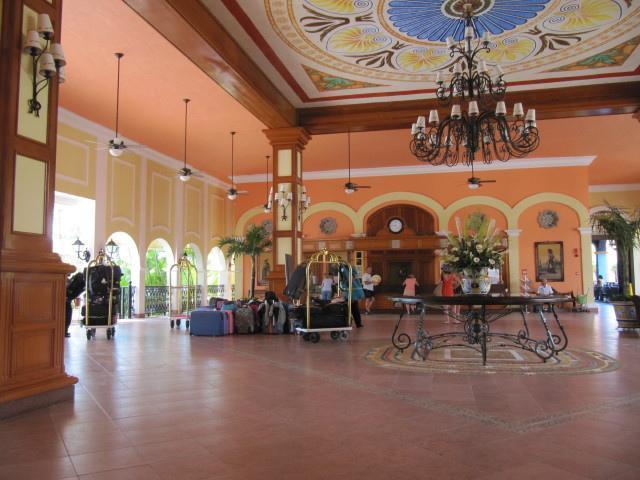How many potted plants are in the photo?
Give a very brief answer. 2. 